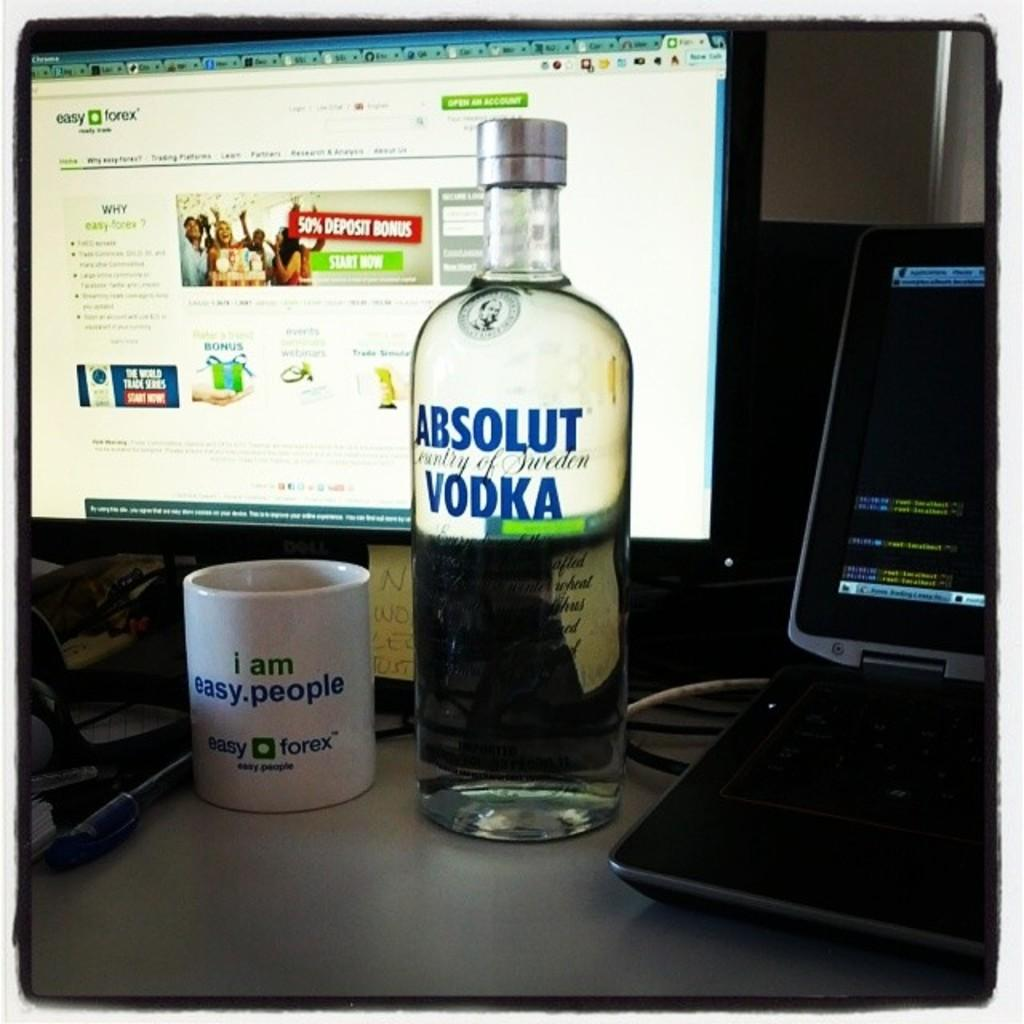<image>
Share a concise interpretation of the image provided. A full bottle of Absolut Vodka on a table with a coffee mug in front of a computer screen. 